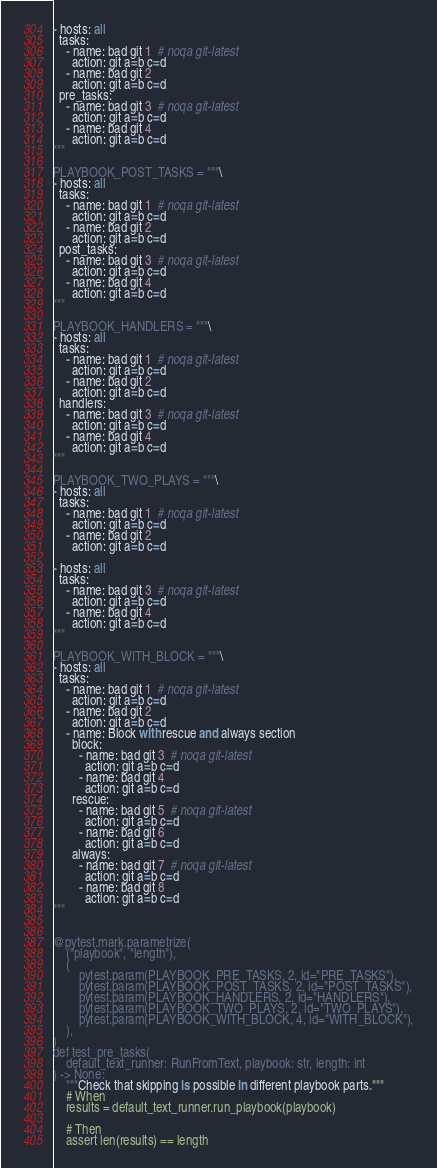<code> <loc_0><loc_0><loc_500><loc_500><_Python_>- hosts: all
  tasks:
    - name: bad git 1  # noqa git-latest
      action: git a=b c=d
    - name: bad git 2
      action: git a=b c=d
  pre_tasks:
    - name: bad git 3  # noqa git-latest
      action: git a=b c=d
    - name: bad git 4
      action: git a=b c=d
"""

PLAYBOOK_POST_TASKS = """\
- hosts: all
  tasks:
    - name: bad git 1  # noqa git-latest
      action: git a=b c=d
    - name: bad git 2
      action: git a=b c=d
  post_tasks:
    - name: bad git 3  # noqa git-latest
      action: git a=b c=d
    - name: bad git 4
      action: git a=b c=d
"""

PLAYBOOK_HANDLERS = """\
- hosts: all
  tasks:
    - name: bad git 1  # noqa git-latest
      action: git a=b c=d
    - name: bad git 2
      action: git a=b c=d
  handlers:
    - name: bad git 3  # noqa git-latest
      action: git a=b c=d
    - name: bad git 4
      action: git a=b c=d
"""

PLAYBOOK_TWO_PLAYS = """\
- hosts: all
  tasks:
    - name: bad git 1  # noqa git-latest
      action: git a=b c=d
    - name: bad git 2
      action: git a=b c=d

- hosts: all
  tasks:
    - name: bad git 3  # noqa git-latest
      action: git a=b c=d
    - name: bad git 4
      action: git a=b c=d
"""

PLAYBOOK_WITH_BLOCK = """\
- hosts: all
  tasks:
    - name: bad git 1  # noqa git-latest
      action: git a=b c=d
    - name: bad git 2
      action: git a=b c=d
    - name: Block with rescue and always section
      block:
        - name: bad git 3  # noqa git-latest
          action: git a=b c=d
        - name: bad git 4
          action: git a=b c=d
      rescue:
        - name: bad git 5  # noqa git-latest
          action: git a=b c=d
        - name: bad git 6
          action: git a=b c=d
      always:
        - name: bad git 7  # noqa git-latest
          action: git a=b c=d
        - name: bad git 8
          action: git a=b c=d
"""


@pytest.mark.parametrize(
    ("playbook", "length"),
    (
        pytest.param(PLAYBOOK_PRE_TASKS, 2, id="PRE_TASKS"),
        pytest.param(PLAYBOOK_POST_TASKS, 2, id="POST_TASKS"),
        pytest.param(PLAYBOOK_HANDLERS, 2, id="HANDLERS"),
        pytest.param(PLAYBOOK_TWO_PLAYS, 2, id="TWO_PLAYS"),
        pytest.param(PLAYBOOK_WITH_BLOCK, 4, id="WITH_BLOCK"),
    ),
)
def test_pre_tasks(
    default_text_runner: RunFromText, playbook: str, length: int
) -> None:
    """Check that skipping is possible in different playbook parts."""
    # When
    results = default_text_runner.run_playbook(playbook)

    # Then
    assert len(results) == length
</code> 